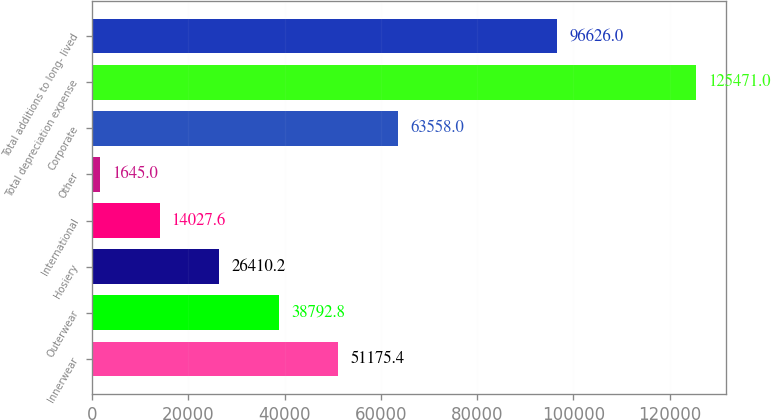Convert chart. <chart><loc_0><loc_0><loc_500><loc_500><bar_chart><fcel>Innerwear<fcel>Outerwear<fcel>Hosiery<fcel>International<fcel>Other<fcel>Corporate<fcel>Total depreciation expense<fcel>Total additions to long- lived<nl><fcel>51175.4<fcel>38792.8<fcel>26410.2<fcel>14027.6<fcel>1645<fcel>63558<fcel>125471<fcel>96626<nl></chart> 